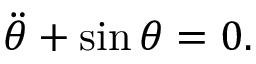Convert formula to latex. <formula><loc_0><loc_0><loc_500><loc_500>\ddot { \theta } + \sin \theta = 0 .</formula> 